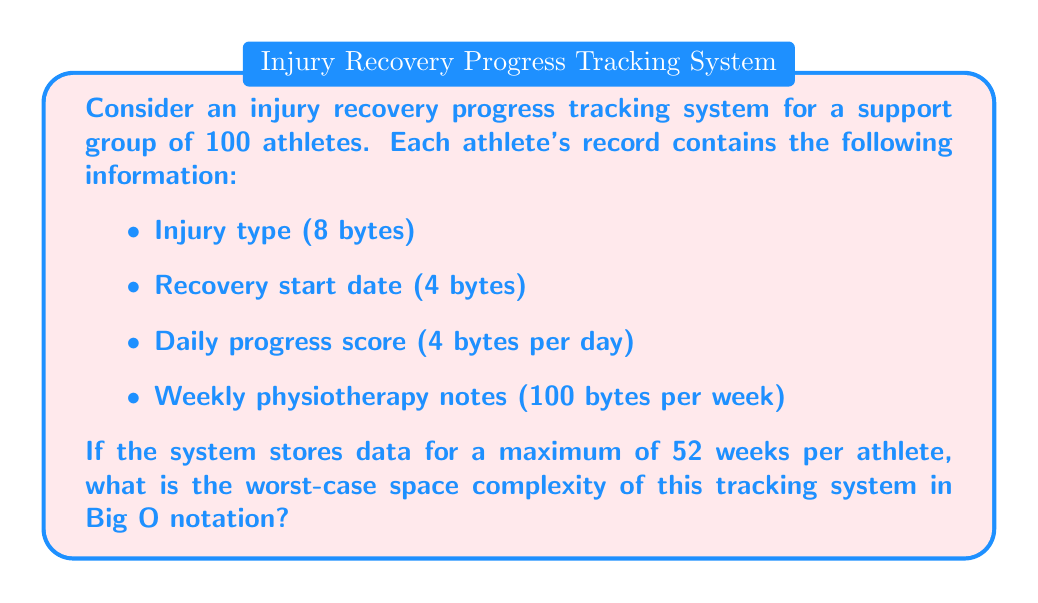Help me with this question. To determine the space complexity, we need to calculate the maximum amount of space required for all athletes' data:

1. Fixed data per athlete:
   - Injury type: 8 bytes
   - Recovery start date: 4 bytes
   Fixed data total: 12 bytes

2. Variable data per athlete (for 52 weeks):
   - Daily progress score: 4 bytes * 7 days * 52 weeks = 1,456 bytes
   - Weekly physiotherapy notes: 100 bytes * 52 weeks = 5,200 bytes
   Variable data total: 6,656 bytes

3. Total data per athlete:
   12 + 6,656 = 6,668 bytes

4. Total data for all 100 athletes:
   6,668 * 100 = 666,800 bytes

The space required grows linearly with the number of athletes. Let $n$ be the number of athletes. The space complexity can be expressed as:

$$ S(n) = 6,668n $$

In Big O notation, we ignore constant factors and consider only the highest-order term. Therefore, the space complexity is $O(n)$.

This linear space complexity holds true regardless of the specific constant (6,668 in this case), as long as the data stored per athlete remains constant and doesn't depend on the total number of athletes.
Answer: $O(n)$, where $n$ is the number of athletes in the system. 